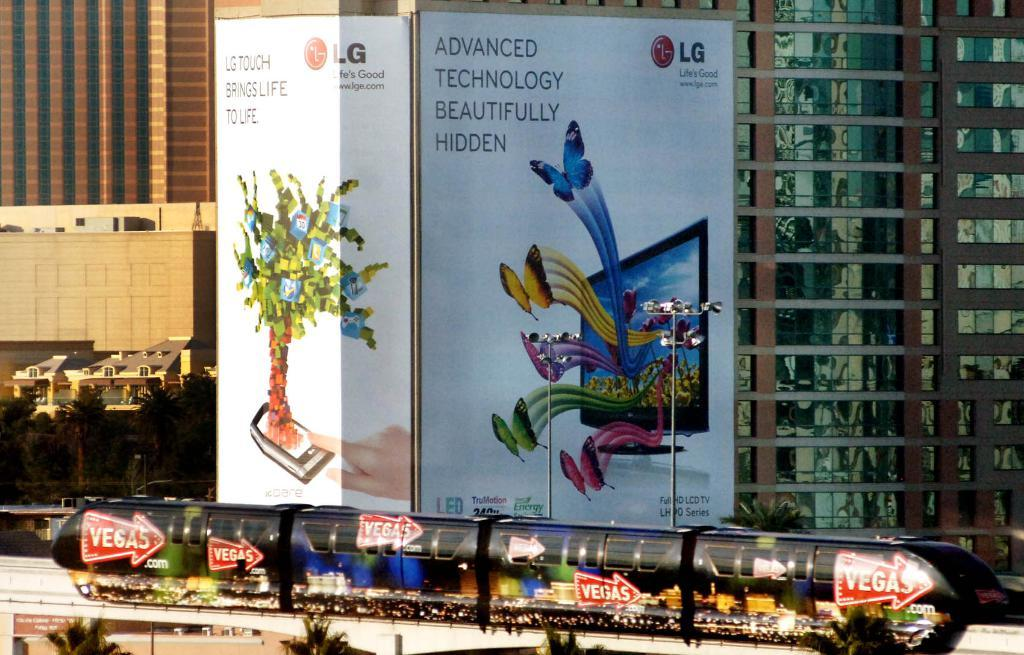<image>
Summarize the visual content of the image. An ad for LG on the side of a building. 